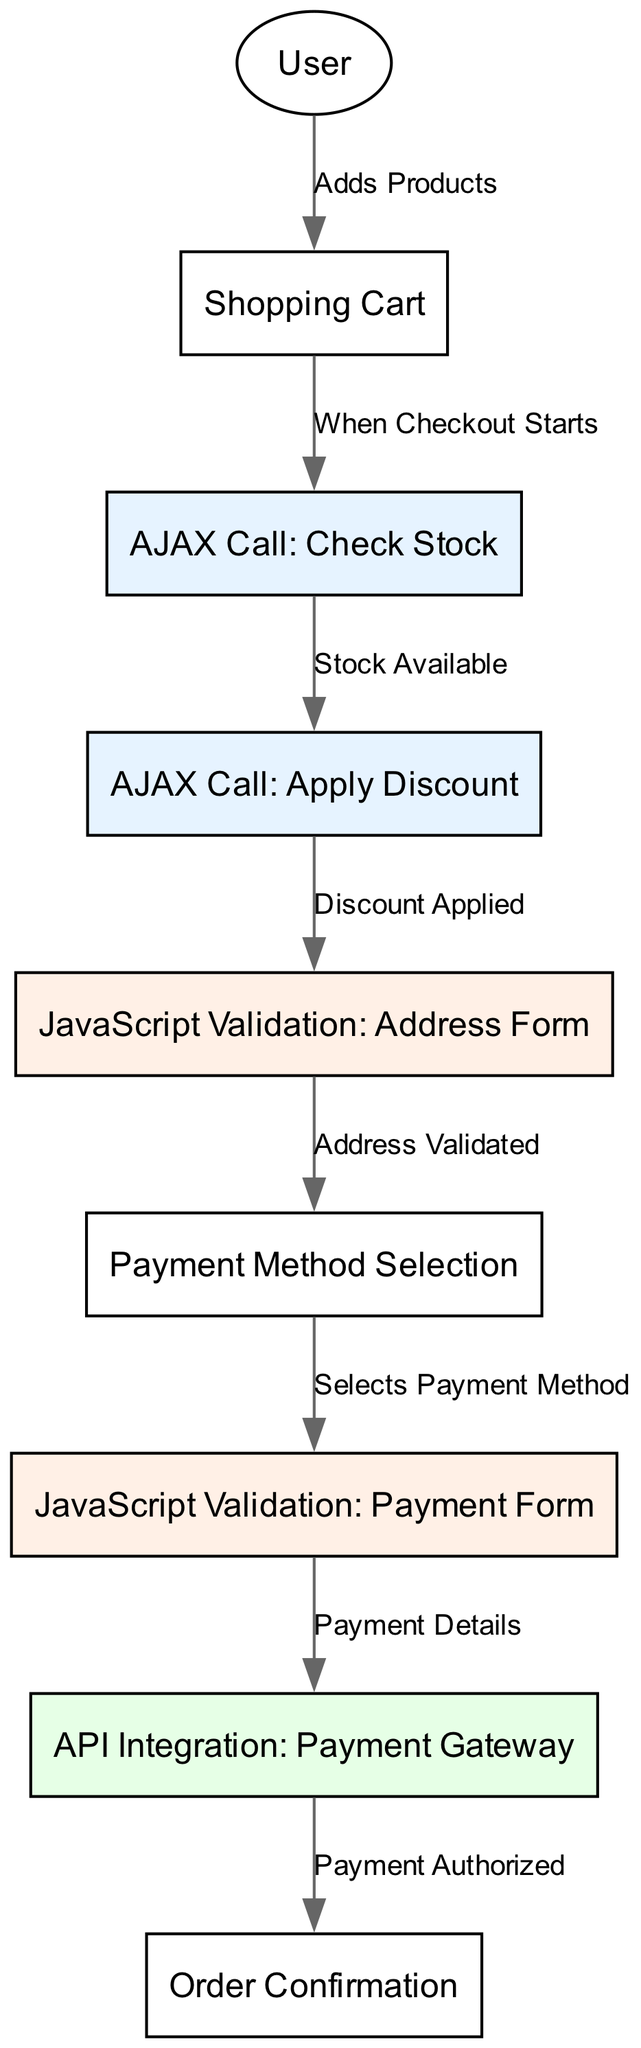What is the first action the user takes in the checkout process? The diagram specifies that the first action is adding products to the shopping cart. This is represented by the edge from the "User" node to the "Shopping Cart" node, labeled "Adds Products."
Answer: Adds Products How many AJAX calls are depicted in the diagram? The diagram lists two AJAX calls: "Check Stock" and "Apply Discount." These are represented as distinct nodes connected by directional edges, indicating the calls in the process.
Answer: 2 What must happen after the "Check Stock" AJAX call if stock is available? After the "Check Stock" AJAX call, if stock is available, the process moves to the "Apply Discount" AJAX call, as indicated by the directed edge connecting these two nodes.
Answer: Apply Discount What is required before the user selects a payment method? The process requires the validation of the address form, represented in the diagram as "JavaScript Validation: Address Form," which must occur after applying any discounts. This flow shows the need for addressing validation before proceeding to payment method selection.
Answer: Address Validated Which integration occurs last in the checkout process? The last integration in the checkout process is the "API Integration: Payment Gateway." This is depicted as a terminal node leading to the "Order Confirmation," signaling the completion of the checkout with a successful payment authorization.
Answer: API Integration: Payment Gateway What happens immediately after the user selects a payment method? After selecting a payment method, the user must complete the "JavaScript Validation: Payment Form." This is shown by the directed edge from "Payment Method Selection" to "JavaScript Validation: Payment Form" in the diagram.
Answer: JavaScript Validation: Payment Form What node indicates the final step in the user checkout process? The final step in the user checkout process is indicated by the "Order Confirmation" node, which serves as the endpoint after successful payment authorization. The edge connection shows that this step follows the "API Integration: Payment Gateway" step.
Answer: Order Confirmation What defines the flow from "Shopping Cart" to "Check Stock"? The flow from the "Shopping Cart" to the "AJAX Call: Check Stock" is initiated when the user starts the checkout process, as labeled in the diagram. This signifies the initial condition necessary to validate stock availability before further actions.
Answer: When Checkout Starts How does the "Apply Discount" AJAX call relate to the "Check Stock" AJAX call? The "Apply Discount" AJAX call only occurs if stock is confirmed available by the "Check Stock" AJAX call. This relationship is illustrated by a directed edge leading from "AJAX Call: Check Stock" to "AJAX Call: Apply Discount," showing the dependency in the process.
Answer: Stock Available 